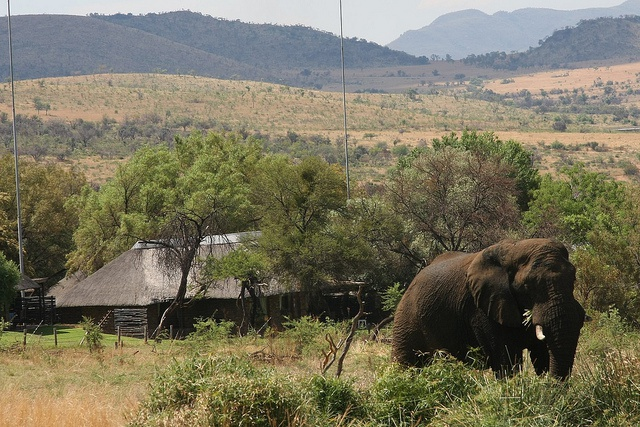Describe the objects in this image and their specific colors. I can see a elephant in lightgray, black, and gray tones in this image. 